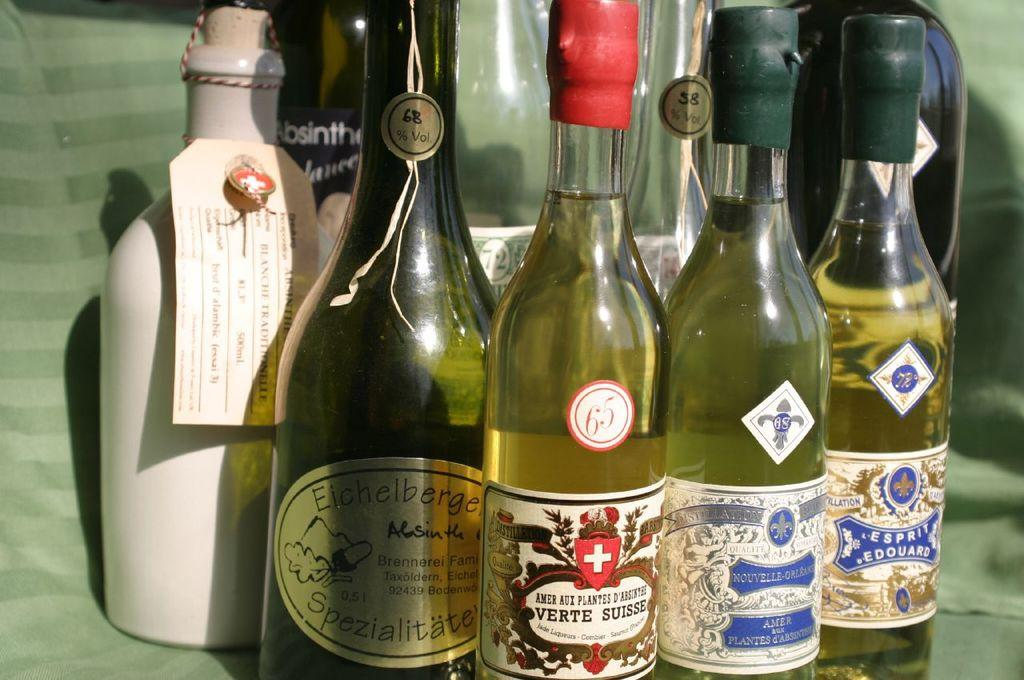<image>
Summarize the visual content of the image. A varied collection of liquor offerings have different alcohol percentages, like 68% and 58%. 